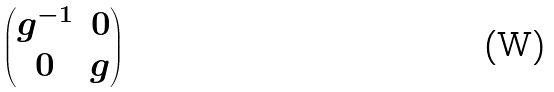Convert formula to latex. <formula><loc_0><loc_0><loc_500><loc_500>\begin{pmatrix} g ^ { - 1 } & 0 \\ 0 & g \end{pmatrix}</formula> 